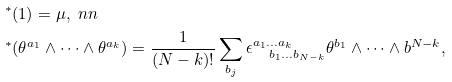Convert formula to latex. <formula><loc_0><loc_0><loc_500><loc_500>& ^ { * } ( 1 ) = \mu , \ n n \\ & ^ { * } ( \theta ^ { a _ { 1 } } \wedge \dots \wedge \theta ^ { a _ { k } } ) = \frac { 1 } { ( N - k ) ! } \sum _ { b _ { j } } \epsilon ^ { a _ { 1 } \dots a _ { k } } _ { \quad b _ { 1 } \dots b _ { N - k } } \theta ^ { b _ { 1 } } \wedge \dots \wedge b ^ { N - k } ,</formula> 